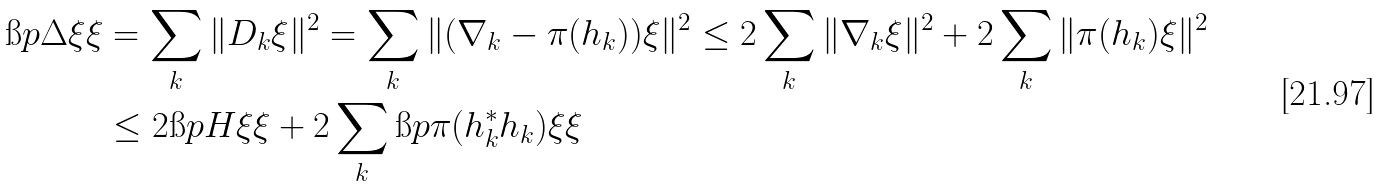<formula> <loc_0><loc_0><loc_500><loc_500>\i p { \Delta \xi } { \xi } & = \sum _ { k } \| D _ { k } \xi \| ^ { 2 } = \sum _ { k } \| ( \nabla _ { k } - \pi ( h _ { k } ) ) \xi \| ^ { 2 } \leq 2 \sum _ { k } \| \nabla _ { k } \xi \| ^ { 2 } + 2 \sum _ { k } \| \pi ( h _ { k } ) \xi \| ^ { 2 } \\ & \leq 2 \i p { H \xi } { \xi } + 2 \sum _ { k } \i p { \pi ( h _ { k } ^ { * } h _ { k } ) \xi } { \xi }</formula> 